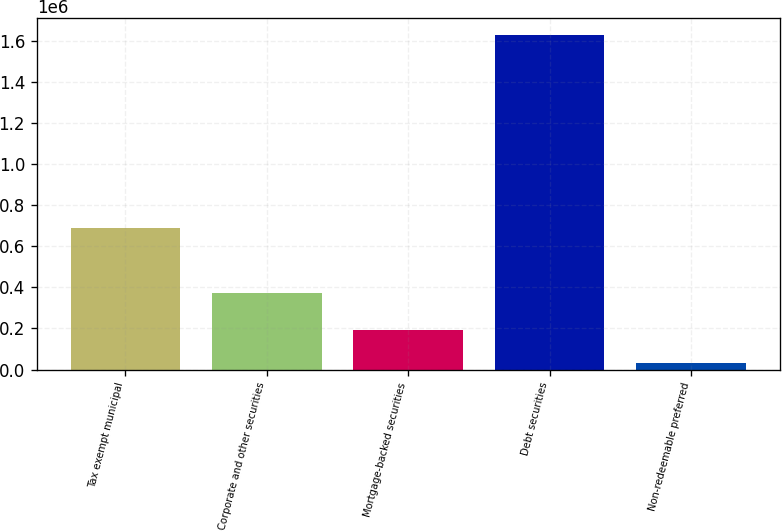Convert chart. <chart><loc_0><loc_0><loc_500><loc_500><bar_chart><fcel>Tax exempt municipal<fcel>Corporate and other securities<fcel>Mortgage-backed securities<fcel>Debt securities<fcel>Non-redeemable preferred<nl><fcel>686552<fcel>374568<fcel>190905<fcel>1.62851e+06<fcel>31171<nl></chart> 